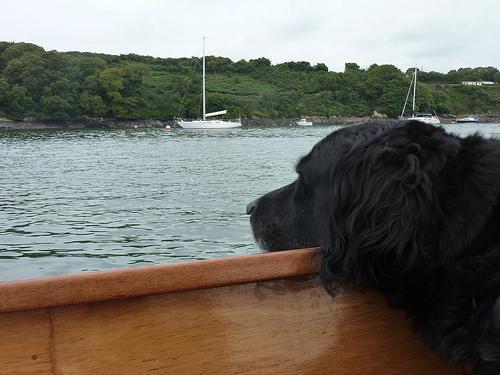How many masts can be seen on the boats?
Give a very brief answer. 2. How many boats can be seen?
Give a very brief answer. 4. 